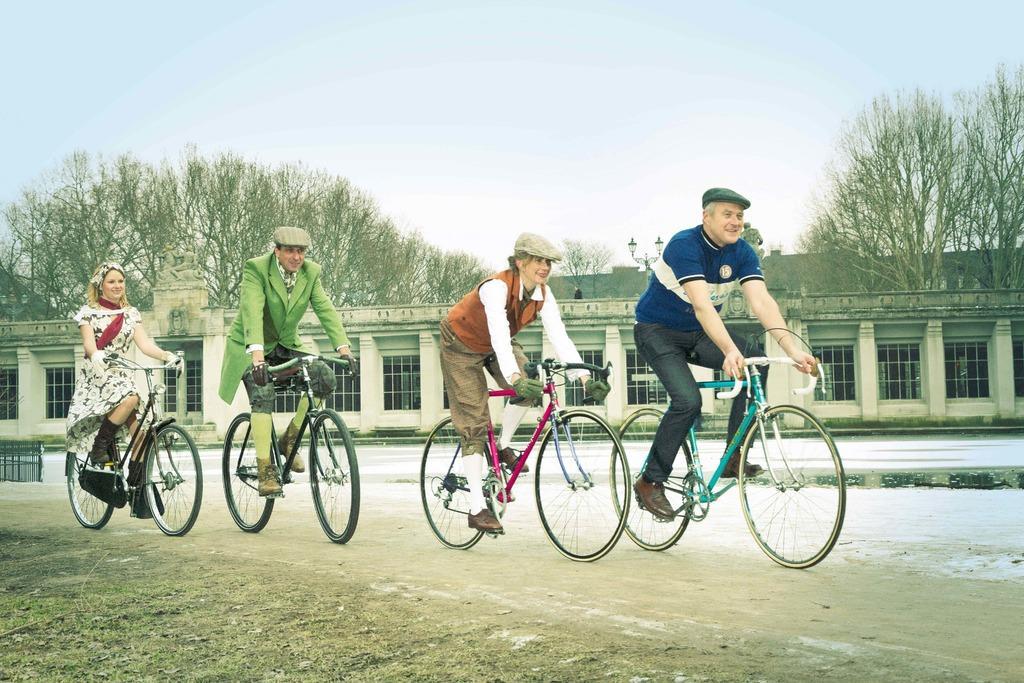Describe this image in one or two sentences. In this image i can see two woman and two man riding bi-cycle on the road, a man wearing blue shirt and black pant, and woman wearing orange shirt and brown pant, a man wearing green dress and a woman wearing white frock. At the background i can see a building, tree and sky. 